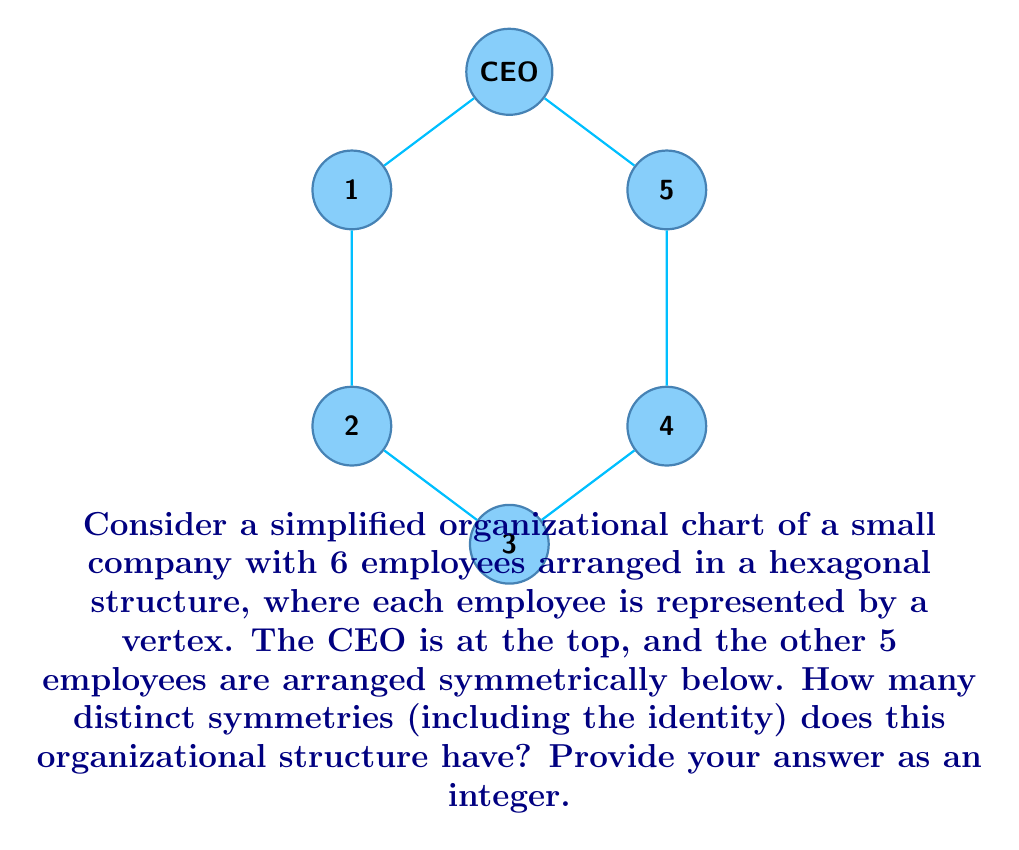Give your solution to this math problem. To solve this problem, we need to analyze the symmetry group of a regular hexagon, as the organizational chart is arranged in this shape. Let's break it down step-by-step:

1) First, let's identify the types of symmetries a regular hexagon has:
   a) Rotational symmetries
   b) Reflectional symmetries

2) Rotational symmetries:
   - A regular hexagon can be rotated by multiples of 60° (or $\frac{\pi}{3}$ radians) to map onto itself.
   - There are 6 rotational symmetries: 0°, 60°, 120°, 180°, 240°, 300°

3) Reflectional symmetries:
   - A regular hexagon has 6 lines of reflection:
     * 3 passing through opposite vertices
     * 3 passing through the midpoints of opposite sides

4) Counting the symmetries:
   - 6 rotational symmetries (including the identity rotation of 0°)
   - 6 reflectional symmetries

5) Total number of symmetries:
   $6 + 6 = 12$

However, we need to consider the special role of the CEO in this organizational chart. The CEO's position must remain fixed in any symmetry operation, which restricts our symmetry group.

6) Considering the CEO's fixed position:
   - Only rotations of 0° (identity) and 180° are allowed
   - Only the 3 reflections through axes passing through the CEO are allowed

7) Final count of symmetries:
   - 2 rotational symmetries (0° and 180°)
   - 3 reflectional symmetries
   - Total: $2 + 3 = 5$

Therefore, the organizational chart has 5 distinct symmetries, including the identity.
Answer: 5 